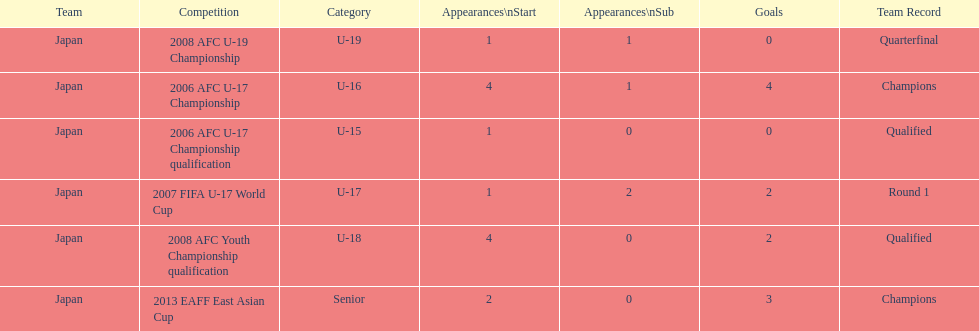Help me parse the entirety of this table. {'header': ['Team', 'Competition', 'Category', 'Appearances\\nStart', 'Appearances\\nSub', 'Goals', 'Team Record'], 'rows': [['Japan', '2008 AFC U-19 Championship', 'U-19', '1', '1', '0', 'Quarterfinal'], ['Japan', '2006 AFC U-17 Championship', 'U-16', '4', '1', '4', 'Champions'], ['Japan', '2006 AFC U-17 Championship qualification', 'U-15', '1', '0', '0', 'Qualified'], ['Japan', '2007 FIFA U-17 World Cup', 'U-17', '1', '2', '2', 'Round 1'], ['Japan', '2008 AFC Youth Championship qualification', 'U-18', '4', '0', '2', 'Qualified'], ['Japan', '2013 EAFF East Asian Cup', 'Senior', '2', '0', '3', 'Champions']]} In which two competitions did japan lack goals? 2006 AFC U-17 Championship qualification, 2008 AFC U-19 Championship. 